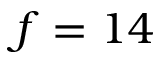<formula> <loc_0><loc_0><loc_500><loc_500>f = 1 4</formula> 